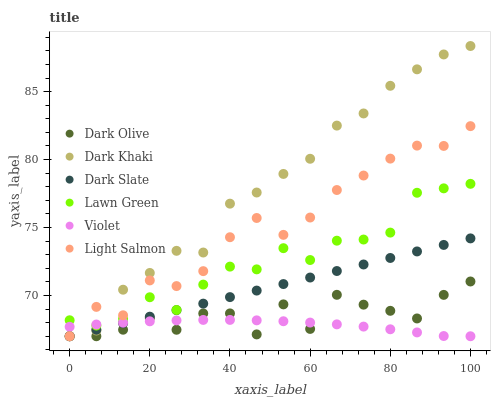Does Violet have the minimum area under the curve?
Answer yes or no. Yes. Does Dark Khaki have the maximum area under the curve?
Answer yes or no. Yes. Does Light Salmon have the minimum area under the curve?
Answer yes or no. No. Does Light Salmon have the maximum area under the curve?
Answer yes or no. No. Is Dark Slate the smoothest?
Answer yes or no. Yes. Is Dark Olive the roughest?
Answer yes or no. Yes. Is Light Salmon the smoothest?
Answer yes or no. No. Is Light Salmon the roughest?
Answer yes or no. No. Does Light Salmon have the lowest value?
Answer yes or no. Yes. Does Dark Khaki have the highest value?
Answer yes or no. Yes. Does Light Salmon have the highest value?
Answer yes or no. No. Is Dark Olive less than Lawn Green?
Answer yes or no. Yes. Is Lawn Green greater than Dark Olive?
Answer yes or no. Yes. Does Light Salmon intersect Lawn Green?
Answer yes or no. Yes. Is Light Salmon less than Lawn Green?
Answer yes or no. No. Is Light Salmon greater than Lawn Green?
Answer yes or no. No. Does Dark Olive intersect Lawn Green?
Answer yes or no. No. 